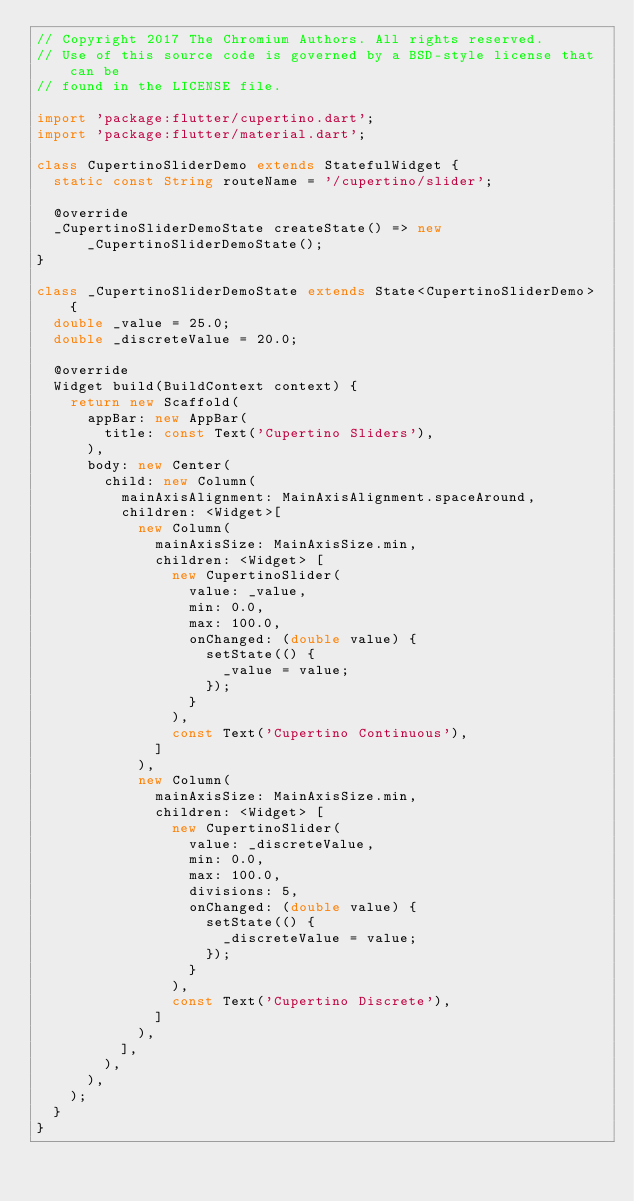Convert code to text. <code><loc_0><loc_0><loc_500><loc_500><_Dart_>// Copyright 2017 The Chromium Authors. All rights reserved.
// Use of this source code is governed by a BSD-style license that can be
// found in the LICENSE file.

import 'package:flutter/cupertino.dart';
import 'package:flutter/material.dart';

class CupertinoSliderDemo extends StatefulWidget {
  static const String routeName = '/cupertino/slider';

  @override
  _CupertinoSliderDemoState createState() => new _CupertinoSliderDemoState();
}

class _CupertinoSliderDemoState extends State<CupertinoSliderDemo> {
  double _value = 25.0;
  double _discreteValue = 20.0;

  @override
  Widget build(BuildContext context) {
    return new Scaffold(
      appBar: new AppBar(
        title: const Text('Cupertino Sliders'),
      ),
      body: new Center(
        child: new Column(
          mainAxisAlignment: MainAxisAlignment.spaceAround,
          children: <Widget>[
            new Column(
              mainAxisSize: MainAxisSize.min,
              children: <Widget> [
                new CupertinoSlider(
                  value: _value,
                  min: 0.0,
                  max: 100.0,
                  onChanged: (double value) {
                    setState(() {
                      _value = value;
                    });
                  }
                ),
                const Text('Cupertino Continuous'),
              ]
            ),
            new Column(
              mainAxisSize: MainAxisSize.min,
              children: <Widget> [
                new CupertinoSlider(
                  value: _discreteValue,
                  min: 0.0,
                  max: 100.0,
                  divisions: 5,
                  onChanged: (double value) {
                    setState(() {
                      _discreteValue = value;
                    });
                  }
                ),
                const Text('Cupertino Discrete'),
              ]
            ),
          ],
        ),
      ),
    );
  }
}
</code> 